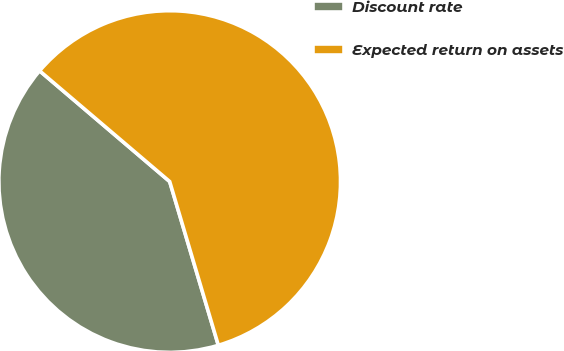Convert chart. <chart><loc_0><loc_0><loc_500><loc_500><pie_chart><fcel>Discount rate<fcel>Expected return on assets<nl><fcel>40.82%<fcel>59.18%<nl></chart> 